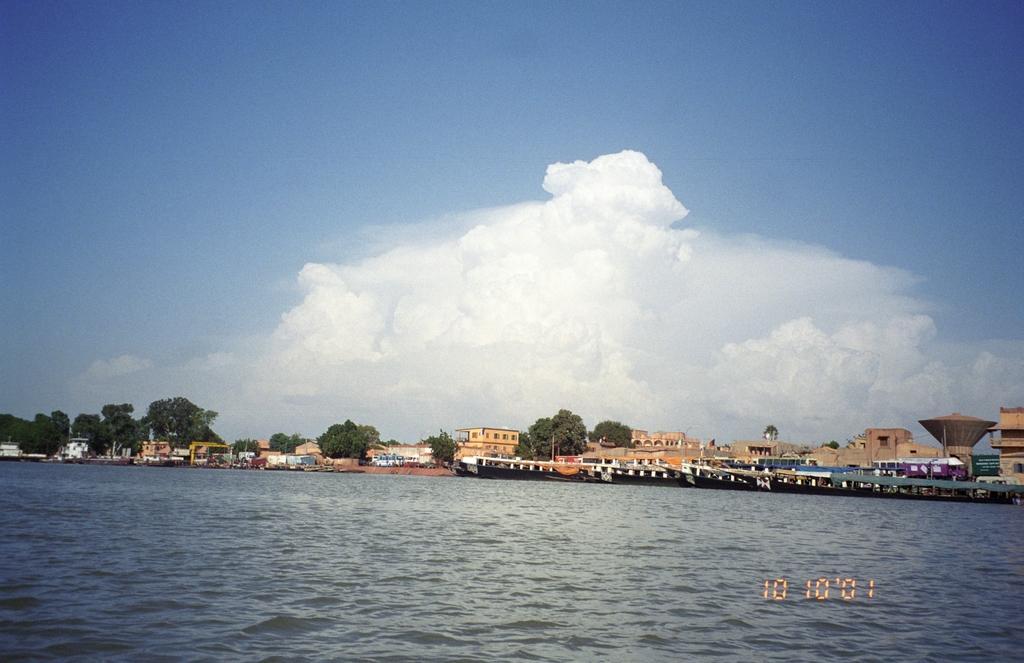How would you summarize this image in a sentence or two? In this image I can see few boats on the water, background I can see trees in green color, buildings in cream and white color, and the sky is in blue and white color. 